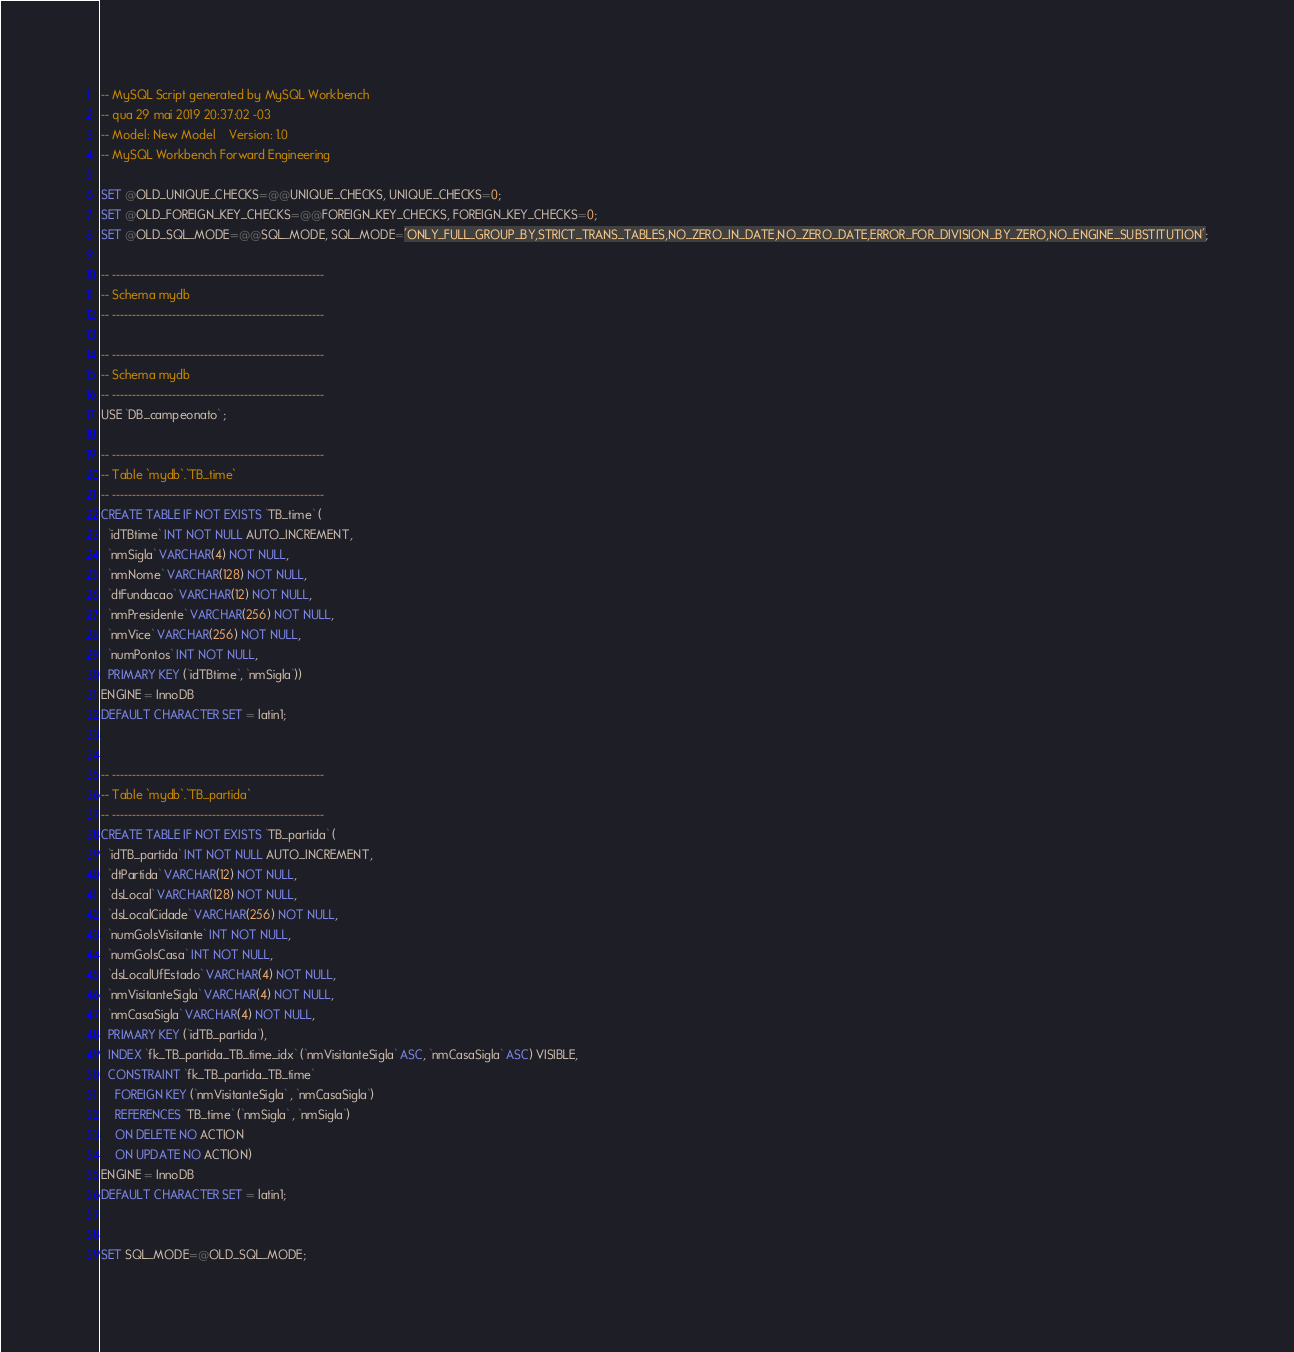<code> <loc_0><loc_0><loc_500><loc_500><_SQL_>-- MySQL Script generated by MySQL Workbench
-- qua 29 mai 2019 20:37:02 -03
-- Model: New Model    Version: 1.0
-- MySQL Workbench Forward Engineering

SET @OLD_UNIQUE_CHECKS=@@UNIQUE_CHECKS, UNIQUE_CHECKS=0;
SET @OLD_FOREIGN_KEY_CHECKS=@@FOREIGN_KEY_CHECKS, FOREIGN_KEY_CHECKS=0;
SET @OLD_SQL_MODE=@@SQL_MODE, SQL_MODE='ONLY_FULL_GROUP_BY,STRICT_TRANS_TABLES,NO_ZERO_IN_DATE,NO_ZERO_DATE,ERROR_FOR_DIVISION_BY_ZERO,NO_ENGINE_SUBSTITUTION';

-- -----------------------------------------------------
-- Schema mydb
-- -----------------------------------------------------

-- -----------------------------------------------------
-- Schema mydb
-- -----------------------------------------------------
USE `DB_campeonato` ;

-- -----------------------------------------------------
-- Table `mydb`.`TB_time`
-- -----------------------------------------------------
CREATE TABLE IF NOT EXISTS `TB_time` (
  `idTBtime` INT NOT NULL AUTO_INCREMENT,
  `nmSigla` VARCHAR(4) NOT NULL,
  `nmNome` VARCHAR(128) NOT NULL,
  `dtFundacao` VARCHAR(12) NOT NULL,
  `nmPresidente` VARCHAR(256) NOT NULL,
  `nmVice` VARCHAR(256) NOT NULL,
  `numPontos` INT NOT NULL,
  PRIMARY KEY (`idTBtime`, `nmSigla`))
ENGINE = InnoDB
DEFAULT CHARACTER SET = latin1;


-- -----------------------------------------------------
-- Table `mydb`.`TB_partida`
-- -----------------------------------------------------
CREATE TABLE IF NOT EXISTS `TB_partida` (
  `idTB_partida` INT NOT NULL AUTO_INCREMENT,
  `dtPartida` VARCHAR(12) NOT NULL,
  `dsLocal` VARCHAR(128) NOT NULL,
  `dsLocalCidade` VARCHAR(256) NOT NULL,
  `numGolsVisitante` INT NOT NULL,
  `numGolsCasa` INT NOT NULL,
  `dsLocalUfEstado` VARCHAR(4) NOT NULL,
  `nmVisitanteSigla` VARCHAR(4) NOT NULL,
  `nmCasaSigla` VARCHAR(4) NOT NULL,
  PRIMARY KEY (`idTB_partida`),
  INDEX `fk_TB_partida_TB_time_idx` (`nmVisitanteSigla` ASC, `nmCasaSigla` ASC) VISIBLE,
  CONSTRAINT `fk_TB_partida_TB_time`
    FOREIGN KEY (`nmVisitanteSigla` , `nmCasaSigla`)
    REFERENCES `TB_time` (`nmSigla` , `nmSigla`)
    ON DELETE NO ACTION
    ON UPDATE NO ACTION)
ENGINE = InnoDB
DEFAULT CHARACTER SET = latin1;


SET SQL_MODE=@OLD_SQL_MODE;</code> 